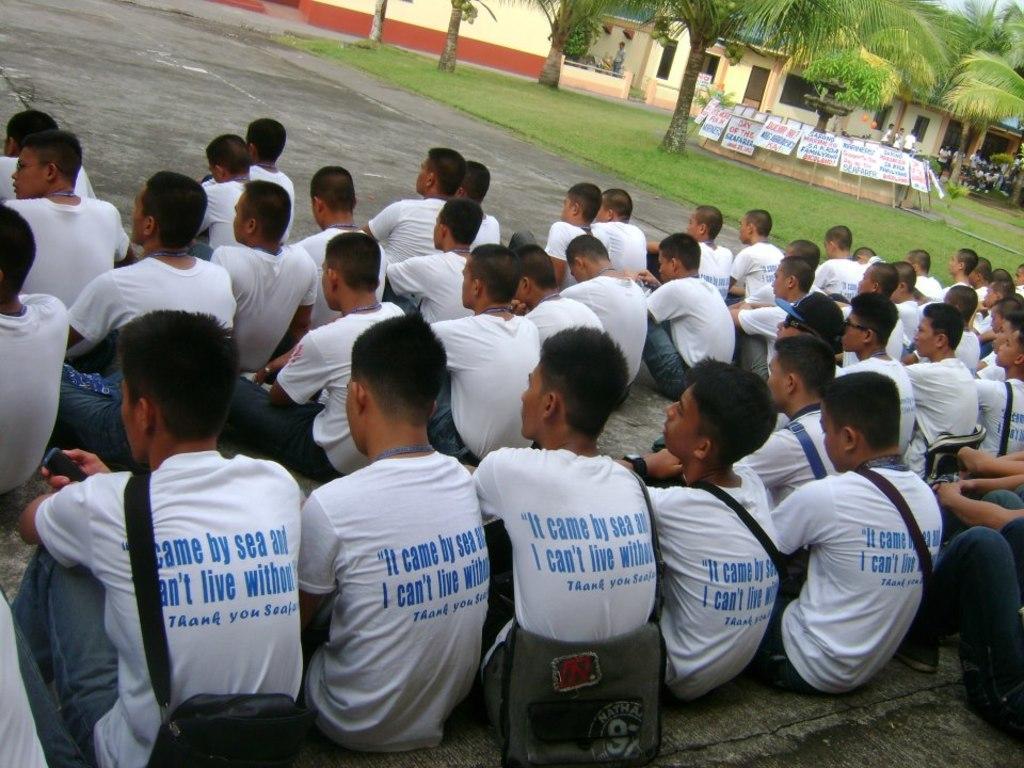Please provide a concise description of this image. In this image in front there are people sitting on the road. On the right side of the image there is grass on the surface. There are placards. There are trees, buildings and we can see a few people in front of the building. 